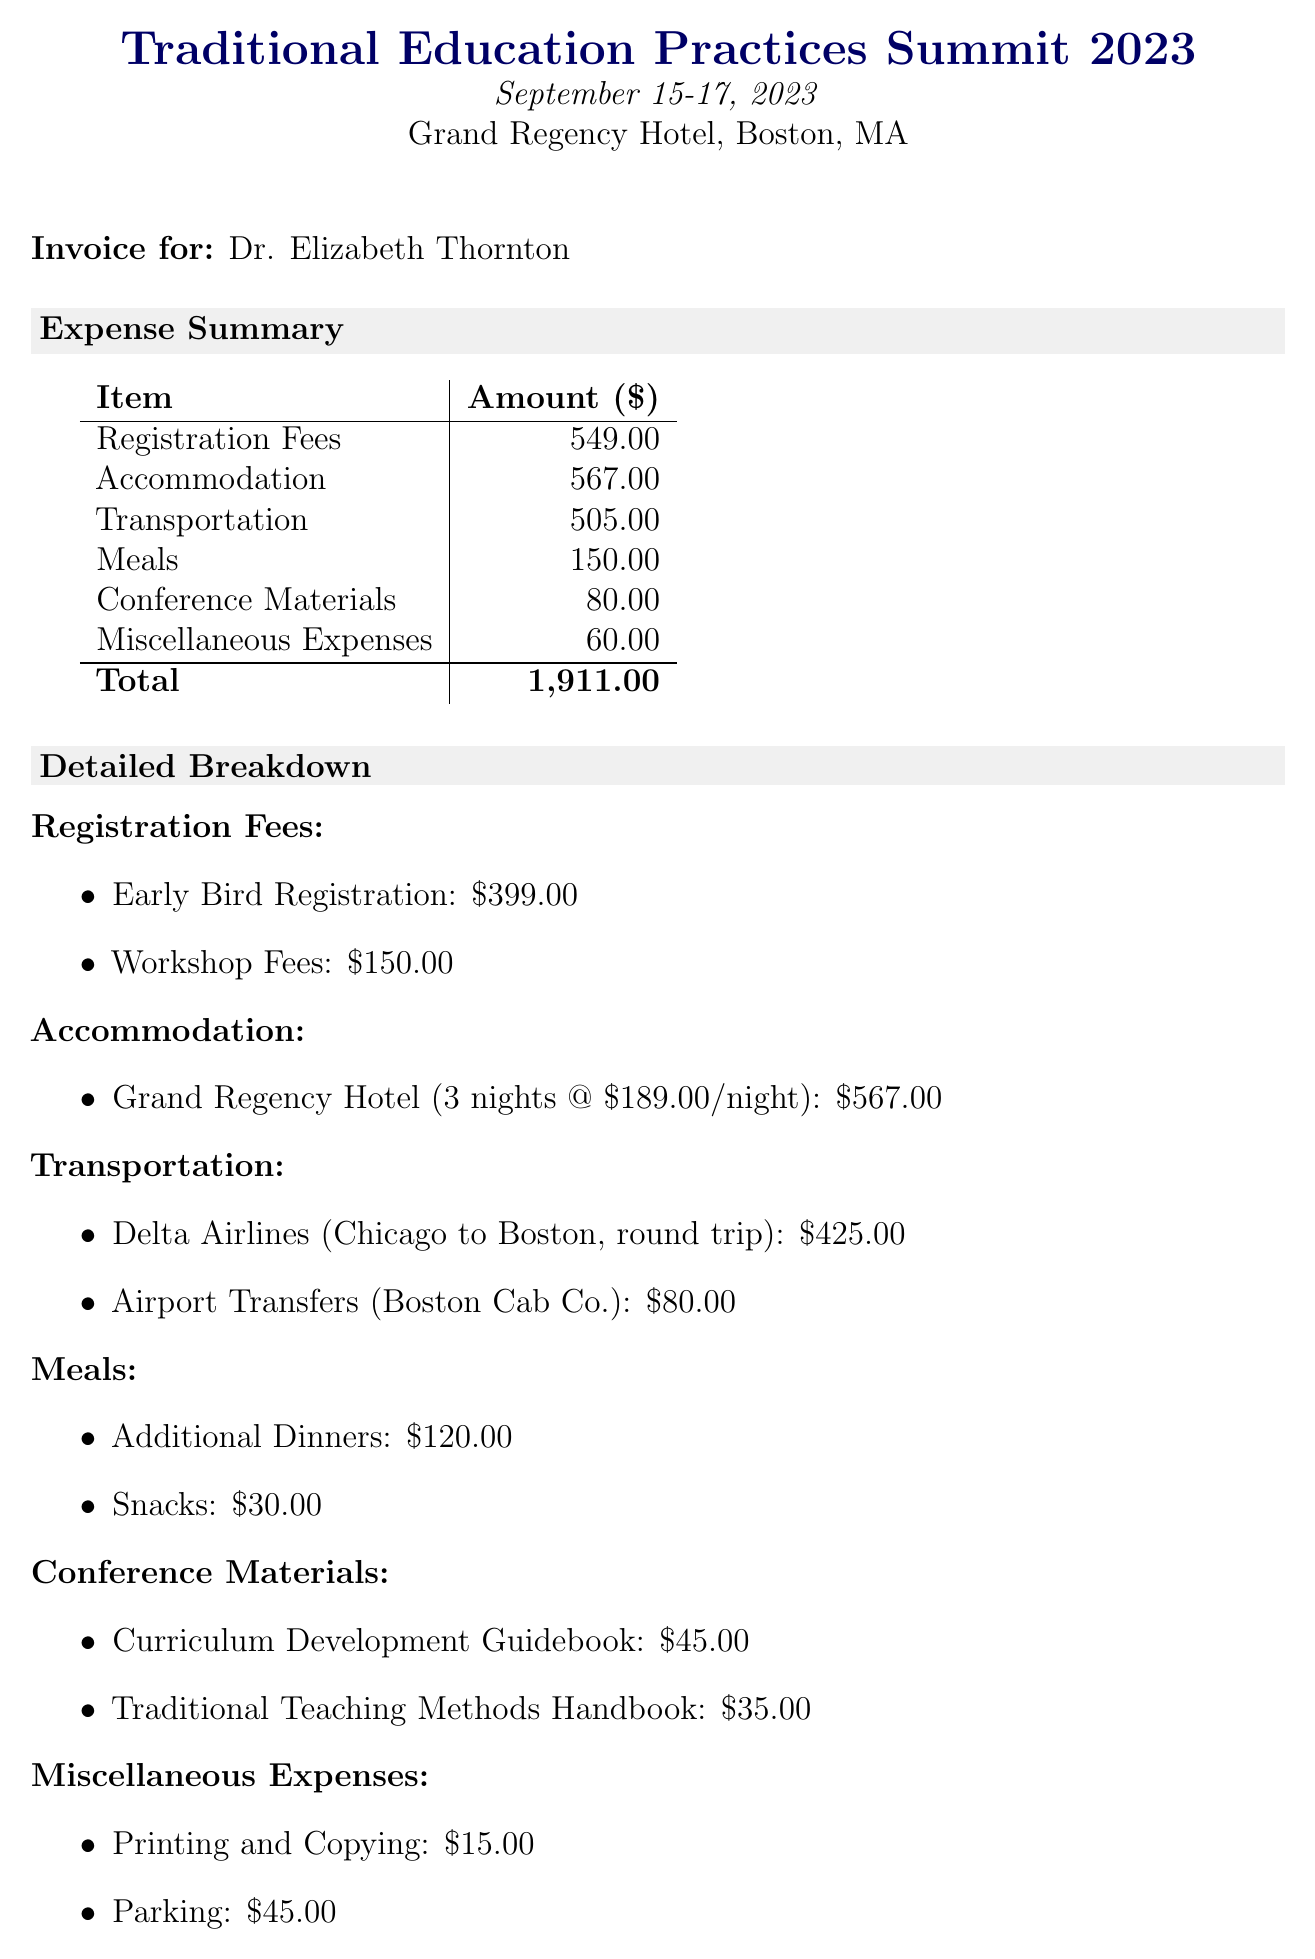What is the name of the conference? The conference name is specifically mentioned in the document under the expense summary, which is "Traditional Education Practices Summit 2023."
Answer: Traditional Education Practices Summit 2023 What are the dates of the conference? The dates of the conference are outlined in the header of the document as September 15-17, 2023.
Answer: September 15-17, 2023 How much was the early bird registration fee? The early bird registration fee is detailed in the registration fees section and is listed as $399.00.
Answer: $399.00 What is the total amount for accommodation? The total accommodation amount is clearly indicated as $567.00 in the expense summary.
Answer: $567.00 Who presented the workshop on discipline techniques? The presenter of the workshop on discipline techniques is mentioned in the workshops attended section as "Prof. Margaret Walsh."
Answer: Prof. Margaret Walsh How much was spent on additional meals? The amount spent on additional meals is provided under the meals section and totals $150.00.
Answer: $150.00 What is the total cost of transportation? The total transportation cost is summed up in the expense summary as $505.00.
Answer: $505.00 How many nights did Dr. Thornton stay at the hotel? The document specifies that the stay at the hotel was for 3 nights.
Answer: 3 nights What is the total expense incurred for the conference? The total expenses are summarized in the document and stated as $1911.00.
Answer: $1911.00 